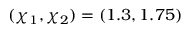Convert formula to latex. <formula><loc_0><loc_0><loc_500><loc_500>( \chi _ { 1 } , \chi _ { 2 } ) = ( 1 . 3 , 1 . 7 5 )</formula> 